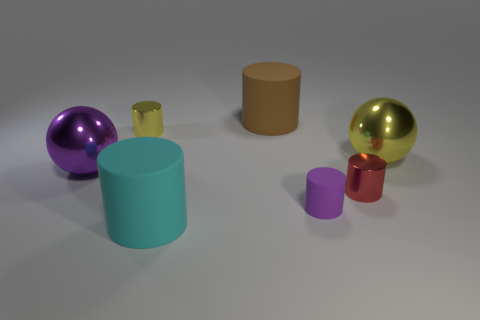What color is the big shiny thing that is to the left of the large rubber cylinder behind the big yellow ball?
Give a very brief answer. Purple. Are there an equal number of brown rubber cylinders on the left side of the small yellow shiny object and big blue metallic objects?
Your response must be concise. Yes. There is a big matte thing that is in front of the metal cylinder that is on the left side of the large brown rubber thing; what number of large rubber cylinders are on the left side of it?
Make the answer very short. 0. There is a matte cylinder behind the big purple shiny thing; what color is it?
Offer a terse response. Brown. There is a cylinder that is to the left of the brown matte thing and in front of the yellow shiny cylinder; what material is it?
Your answer should be very brief. Rubber. What number of large things are in front of the large brown cylinder that is left of the tiny purple cylinder?
Offer a terse response. 3. What is the shape of the large cyan matte object?
Offer a very short reply. Cylinder. There is a tiny yellow thing that is made of the same material as the tiny red thing; what is its shape?
Provide a succinct answer. Cylinder. Does the matte thing that is behind the big yellow metal object have the same shape as the tiny purple matte object?
Provide a short and direct response. Yes. There is a large yellow metallic thing behind the large purple metallic sphere; what shape is it?
Ensure brevity in your answer.  Sphere. 